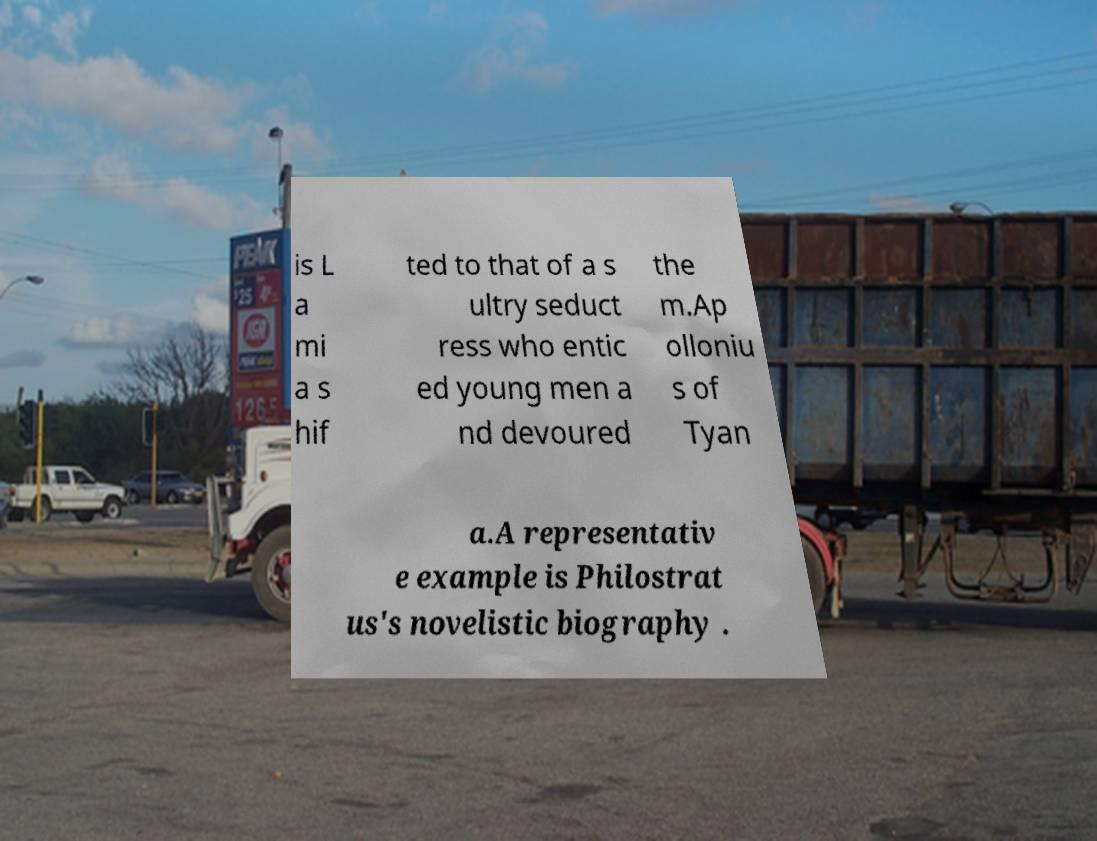Could you extract and type out the text from this image? is L a mi a s hif ted to that of a s ultry seduct ress who entic ed young men a nd devoured the m.Ap olloniu s of Tyan a.A representativ e example is Philostrat us's novelistic biography . 